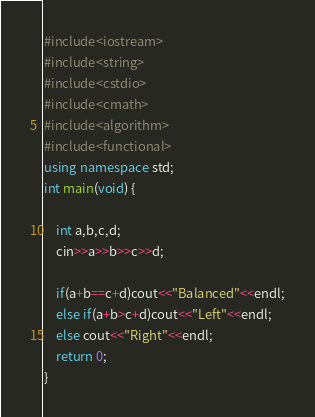Convert code to text. <code><loc_0><loc_0><loc_500><loc_500><_C++_>#include<iostream>
#include<string>
#include<cstdio>
#include<cmath>
#include<algorithm>
#include<functional>
using namespace std;
int main(void) {
    
    int a,b,c,d;
    cin>>a>>b>>c>>d;

    if(a+b==c+d)cout<<"Balanced"<<endl;
    else if(a+b>c+d)cout<<"Left"<<endl;
    else cout<<"Right"<<endl;
    return 0;
}</code> 